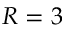Convert formula to latex. <formula><loc_0><loc_0><loc_500><loc_500>R = 3</formula> 